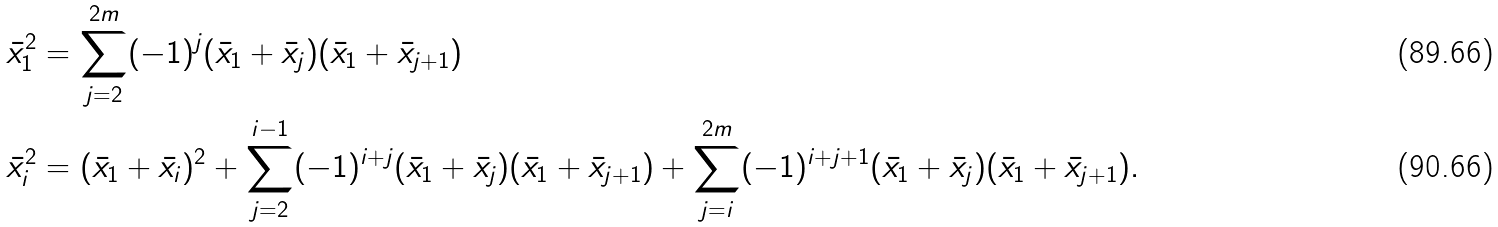<formula> <loc_0><loc_0><loc_500><loc_500>\bar { x } _ { 1 } ^ { 2 } & = \sum _ { j = 2 } ^ { 2 m } ( - 1 ) ^ { j } ( \bar { x } _ { 1 } + \bar { x } _ { j } ) ( \bar { x } _ { 1 } + \bar { x } _ { j + 1 } ) \\ \bar { x } _ { i } ^ { 2 } & = ( \bar { x } _ { 1 } + \bar { x } _ { i } ) ^ { 2 } + \sum _ { j = 2 } ^ { i - 1 } ( - 1 ) ^ { i + j } ( \bar { x } _ { 1 } + \bar { x } _ { j } ) ( \bar { x } _ { 1 } + \bar { x } _ { j + 1 } ) + \sum _ { j = i } ^ { 2 m } ( - 1 ) ^ { i + j + 1 } ( \bar { x } _ { 1 } + \bar { x } _ { j } ) ( \bar { x } _ { 1 } + \bar { x } _ { j + 1 } ) .</formula> 